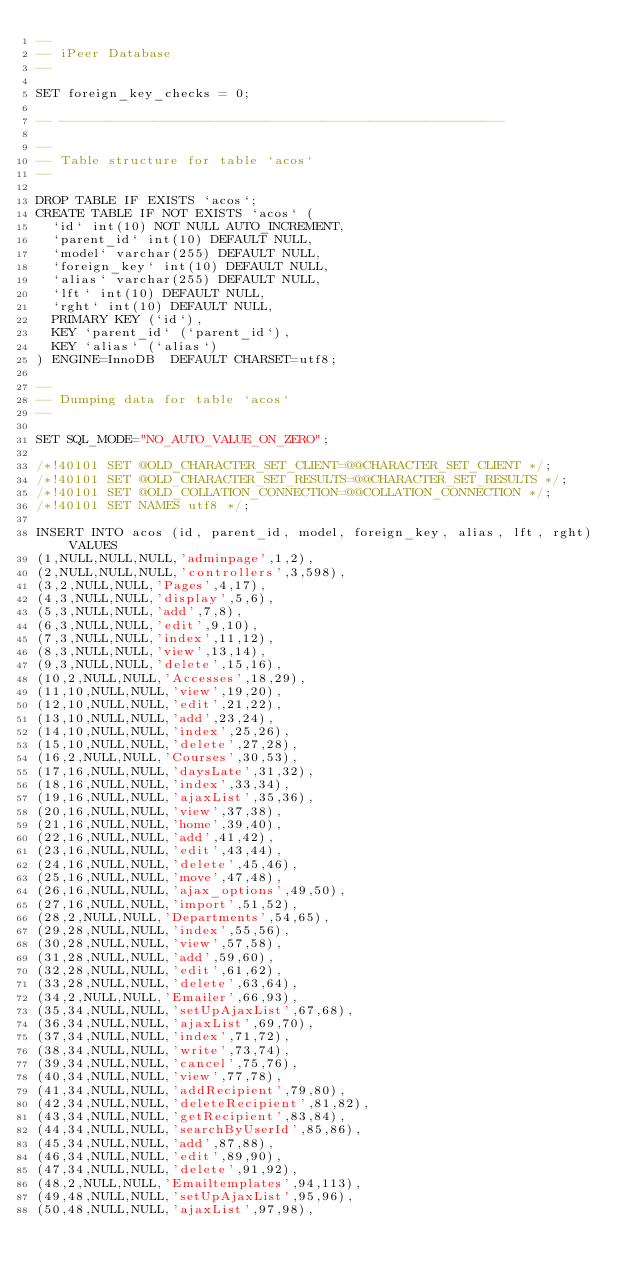<code> <loc_0><loc_0><loc_500><loc_500><_SQL_>--
-- iPeer Database
--

SET foreign_key_checks = 0;

-- --------------------------------------------------------

--
-- Table structure for table `acos`
--

DROP TABLE IF EXISTS `acos`;
CREATE TABLE IF NOT EXISTS `acos` (
  `id` int(10) NOT NULL AUTO_INCREMENT,
  `parent_id` int(10) DEFAULT NULL,
  `model` varchar(255) DEFAULT NULL,
  `foreign_key` int(10) DEFAULT NULL,
  `alias` varchar(255) DEFAULT NULL,
  `lft` int(10) DEFAULT NULL,
  `rght` int(10) DEFAULT NULL,
  PRIMARY KEY (`id`),
  KEY `parent_id` (`parent_id`),
  KEY `alias` (`alias`)
) ENGINE=InnoDB  DEFAULT CHARSET=utf8;

--
-- Dumping data for table `acos`
--

SET SQL_MODE="NO_AUTO_VALUE_ON_ZERO";

/*!40101 SET @OLD_CHARACTER_SET_CLIENT=@@CHARACTER_SET_CLIENT */;
/*!40101 SET @OLD_CHARACTER_SET_RESULTS=@@CHARACTER_SET_RESULTS */;
/*!40101 SET @OLD_COLLATION_CONNECTION=@@COLLATION_CONNECTION */;
/*!40101 SET NAMES utf8 */;

INSERT INTO acos (id, parent_id, model, foreign_key, alias, lft, rght) VALUES
(1,NULL,NULL,NULL,'adminpage',1,2),
(2,NULL,NULL,NULL,'controllers',3,598),
(3,2,NULL,NULL,'Pages',4,17),
(4,3,NULL,NULL,'display',5,6),
(5,3,NULL,NULL,'add',7,8),
(6,3,NULL,NULL,'edit',9,10),
(7,3,NULL,NULL,'index',11,12),
(8,3,NULL,NULL,'view',13,14),
(9,3,NULL,NULL,'delete',15,16),
(10,2,NULL,NULL,'Accesses',18,29),
(11,10,NULL,NULL,'view',19,20),
(12,10,NULL,NULL,'edit',21,22),
(13,10,NULL,NULL,'add',23,24),
(14,10,NULL,NULL,'index',25,26),
(15,10,NULL,NULL,'delete',27,28),
(16,2,NULL,NULL,'Courses',30,53),
(17,16,NULL,NULL,'daysLate',31,32),
(18,16,NULL,NULL,'index',33,34),
(19,16,NULL,NULL,'ajaxList',35,36),
(20,16,NULL,NULL,'view',37,38),
(21,16,NULL,NULL,'home',39,40),
(22,16,NULL,NULL,'add',41,42),
(23,16,NULL,NULL,'edit',43,44),
(24,16,NULL,NULL,'delete',45,46),
(25,16,NULL,NULL,'move',47,48),
(26,16,NULL,NULL,'ajax_options',49,50),
(27,16,NULL,NULL,'import',51,52),
(28,2,NULL,NULL,'Departments',54,65),
(29,28,NULL,NULL,'index',55,56),
(30,28,NULL,NULL,'view',57,58),
(31,28,NULL,NULL,'add',59,60),
(32,28,NULL,NULL,'edit',61,62),
(33,28,NULL,NULL,'delete',63,64),
(34,2,NULL,NULL,'Emailer',66,93),
(35,34,NULL,NULL,'setUpAjaxList',67,68),
(36,34,NULL,NULL,'ajaxList',69,70),
(37,34,NULL,NULL,'index',71,72),
(38,34,NULL,NULL,'write',73,74),
(39,34,NULL,NULL,'cancel',75,76),
(40,34,NULL,NULL,'view',77,78),
(41,34,NULL,NULL,'addRecipient',79,80),
(42,34,NULL,NULL,'deleteRecipient',81,82),
(43,34,NULL,NULL,'getRecipient',83,84),
(44,34,NULL,NULL,'searchByUserId',85,86),
(45,34,NULL,NULL,'add',87,88),
(46,34,NULL,NULL,'edit',89,90),
(47,34,NULL,NULL,'delete',91,92),
(48,2,NULL,NULL,'Emailtemplates',94,113),
(49,48,NULL,NULL,'setUpAjaxList',95,96),
(50,48,NULL,NULL,'ajaxList',97,98),</code> 